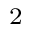<formula> <loc_0><loc_0><loc_500><loc_500>_ { 2 }</formula> 